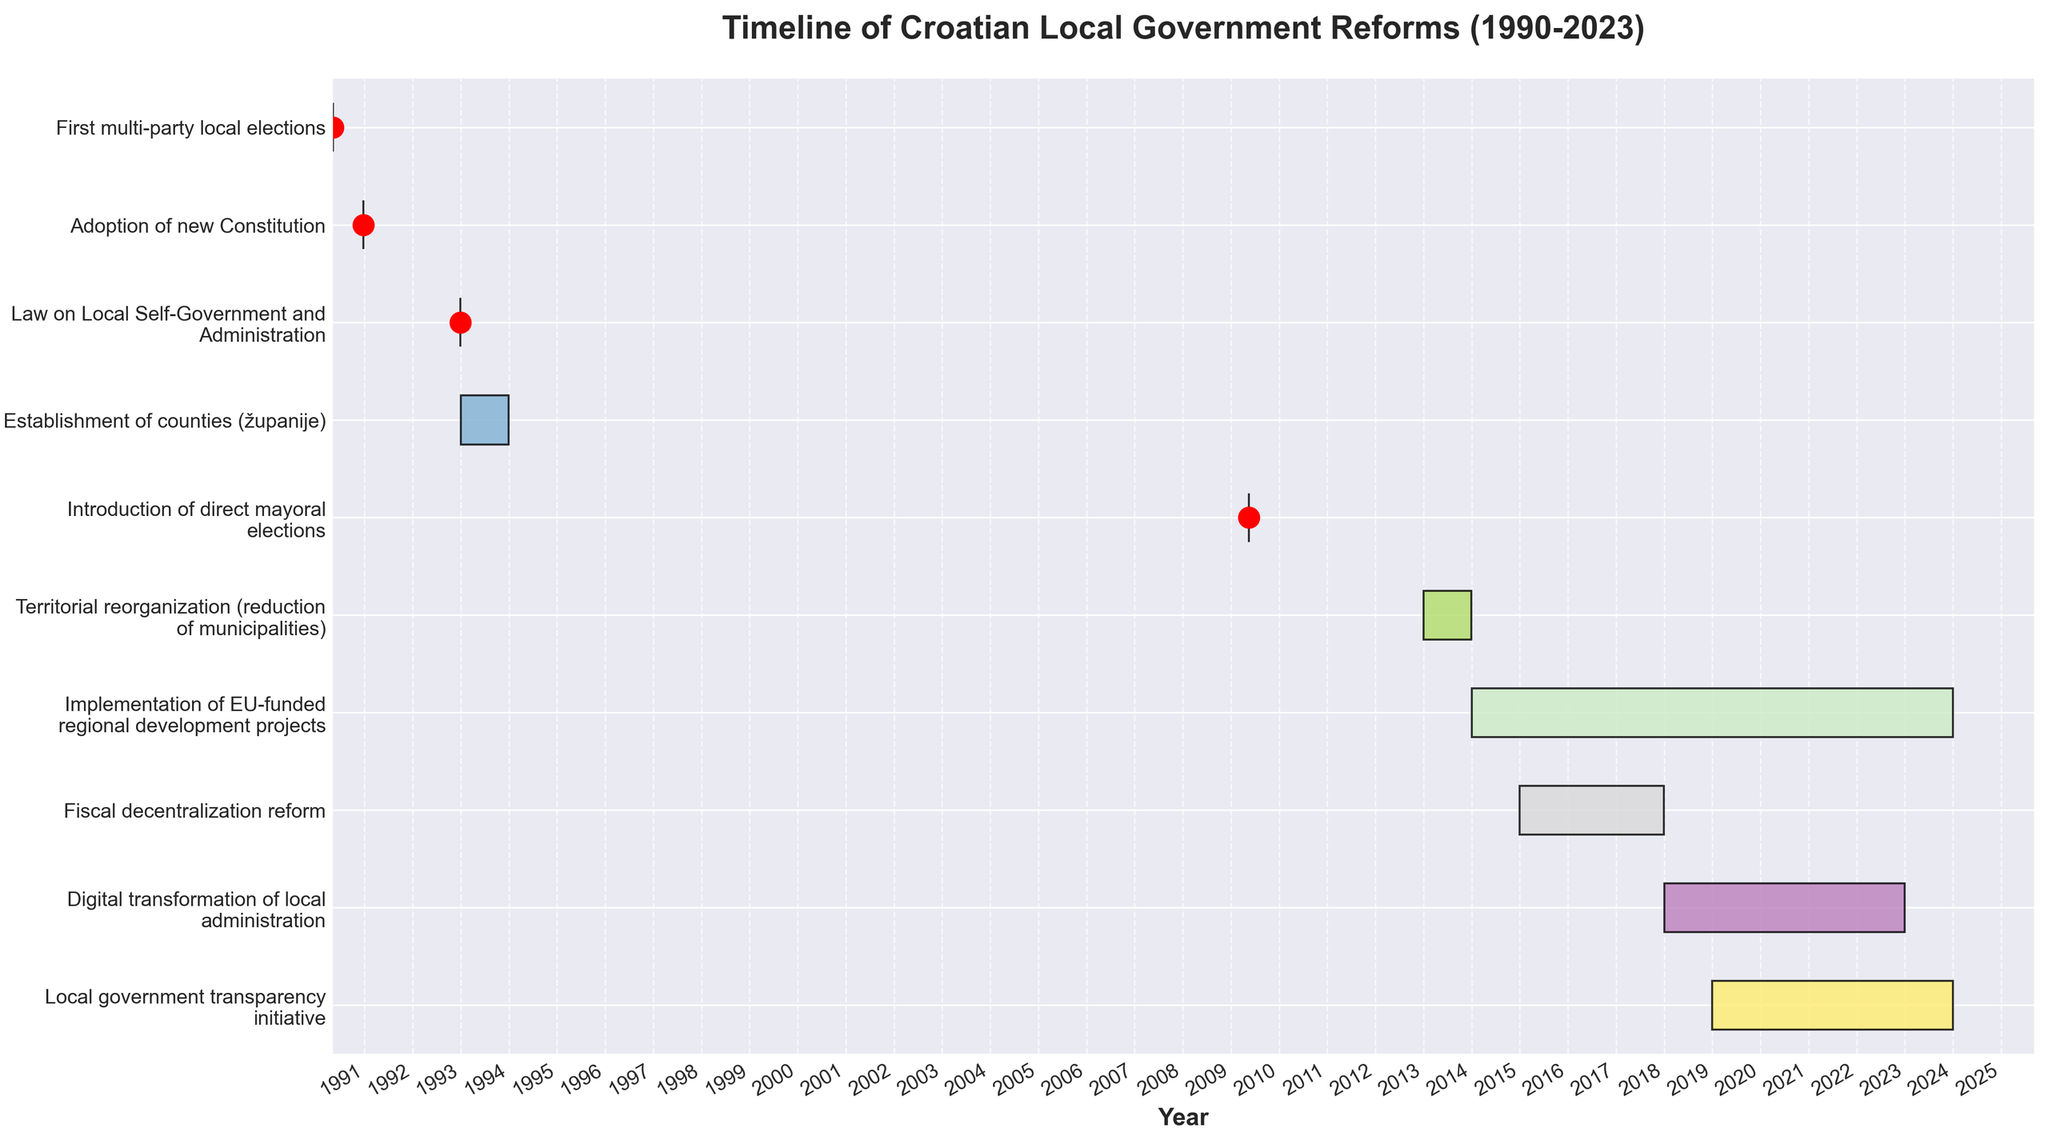What is the title of the Gantt Chart? The title is located at the top center of the chart. It summarizes the overall content.
Answer: Timeline of Croatian Local Government Reforms (1990-2023) Which reform had the shortest duration? By looking at the lengths of the bars, the shortest duration corresponds to the reforms represented as points (i.e., events that happened on a single day).
Answer: Adoption of new Constitution, First multi-party local elections, Law on Local Self-Government and Administration, and Introduction of direct mayoral elections each had a duration of one day When did the Fiscal Decentralization Reform start and end? Locate the "Fiscal decentralization reform" bar on the chart and check the start and end points on the x-axis.
Answer: Start: 2015, End: 2017 How many reforms are depicted in the Gantt Chart? Count the number of horizontal bars or events listed on the y-axis.
Answer: 10 Which reform had the longest duration? Look for the longest horizontal bar span-wise across the x-axis.
Answer: Implementation of EU-funded regional development projects How long did the Digital Transformation of Local Administration last? Find the "Digital transformation of local administration" bar, then calculate the difference between the start and end years.
Answer: 4 years Which two reforms overlapped in the timeline? Identify bars that cover the same time period on the x-axis.
Answer: Fiscal decentralization reform and Implementation of EU-funded regional development projects During which period did Territorial Reorganization (reduction of municipalities) take place? Locate the "Territorial reorganization (reduction of municipalities)" bar on the chart and refer to the x-axis for the time period it covers.
Answer: 2013 Was the Local Government Transparency Initiative ongoing as of 2022? Check the end date for the "Local government transparency initiative" on the chart.
Answer: Yes What was the sequence of reforms starting from after 2000? Observe the start dates of the reforms listed after the year 2000 and arrange them in chronological order.
Answer: Introduction of direct mayoral elections (2009), Territorial reorganization (reduction of municipalities) (2013), Implementation of EU-funded regional development projects (2014), Fiscal decentralization reform (2015), Digital transformation of local administration (2018), Local government transparency initiative (2019) 